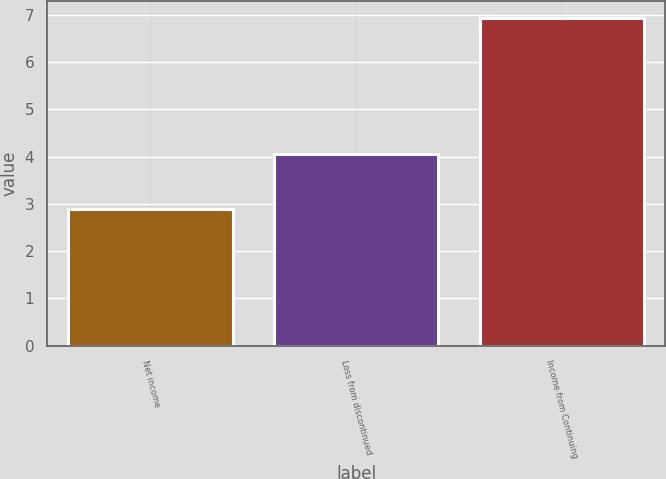Convert chart. <chart><loc_0><loc_0><loc_500><loc_500><bar_chart><fcel>Net income<fcel>Loss from discontinued<fcel>Income from Continuing<nl><fcel>2.89<fcel>4.05<fcel>6.94<nl></chart> 